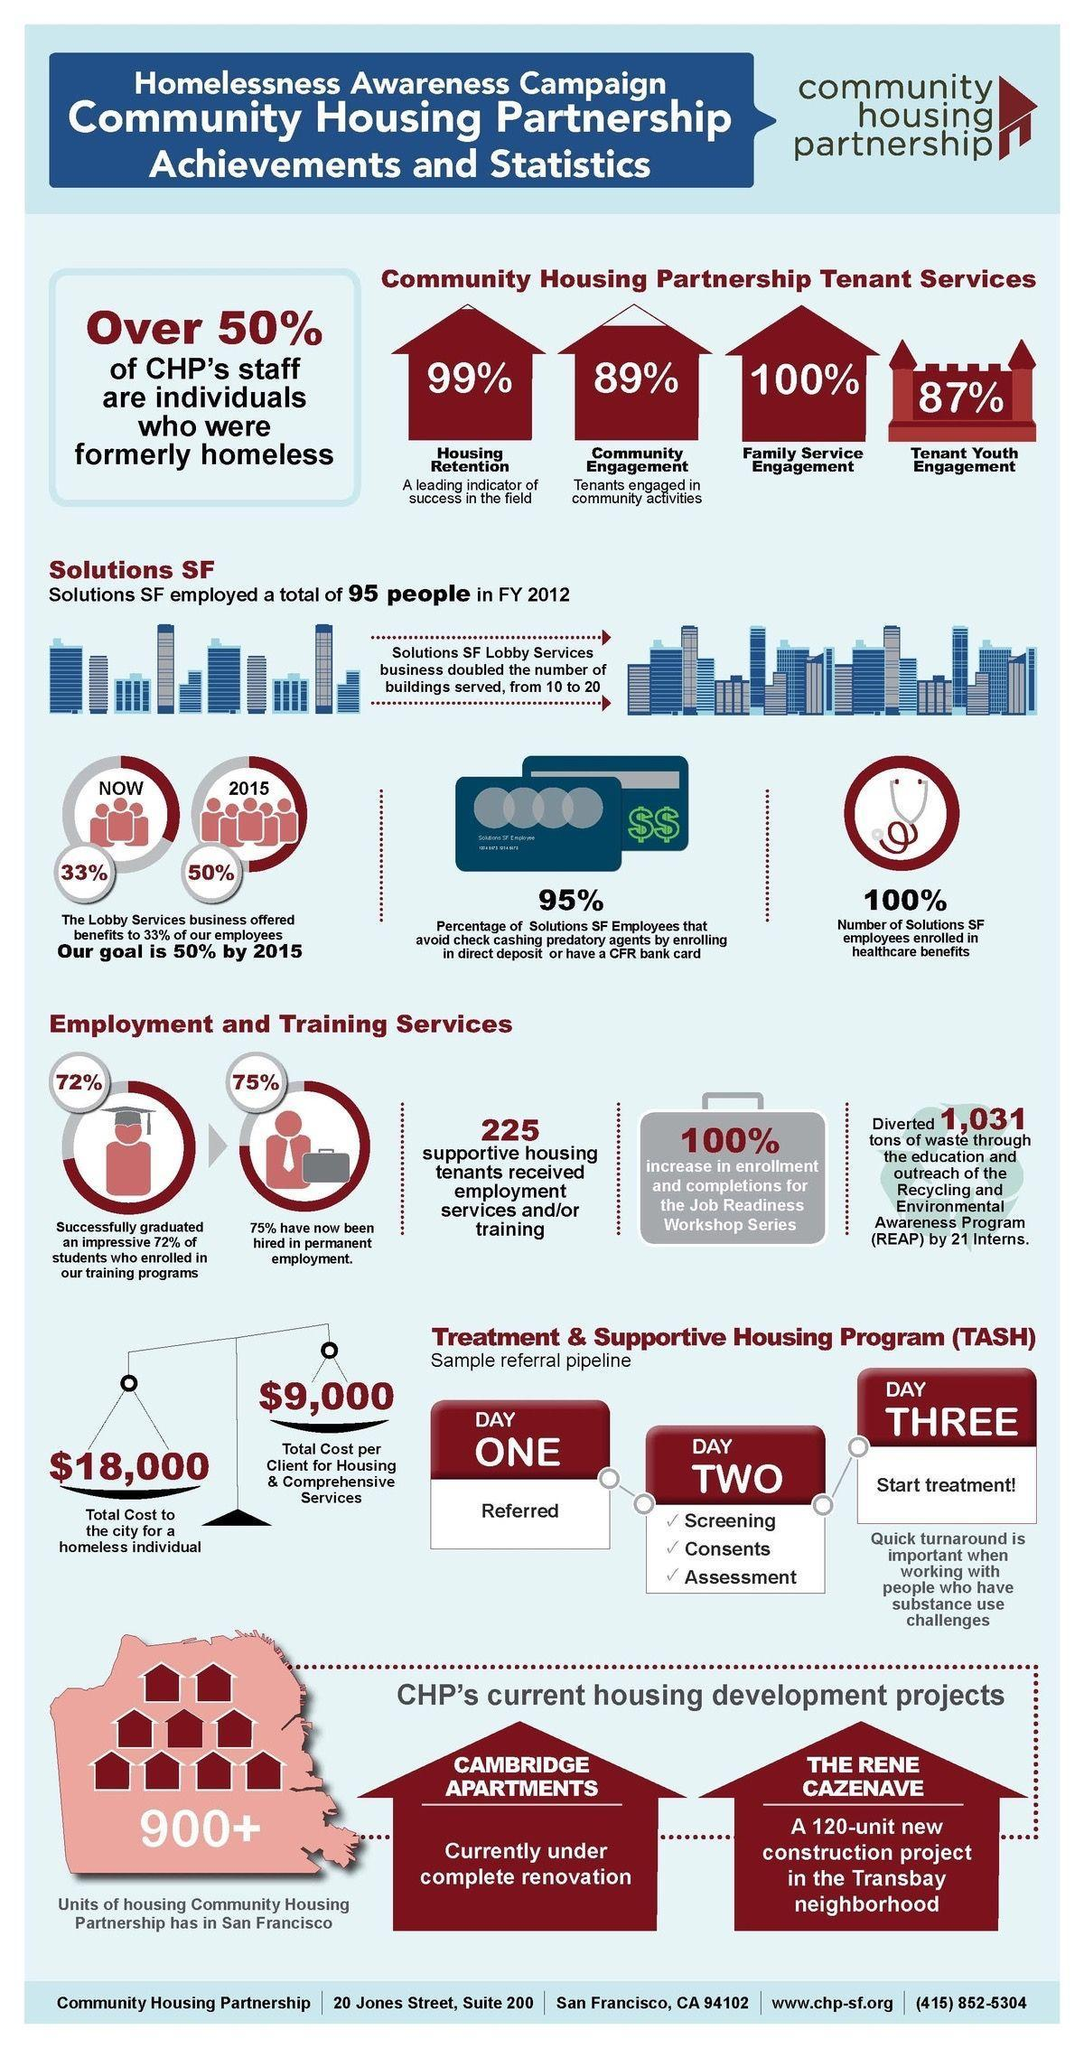What is the expected percentage of benefits offered by the lobby services business by 2015?
Answer the question with a short phrase. 50% What is the number of supportive housing tenants who has received employment and/or training? 225 What percentage of CHP's tenant services are for family service engagement? 100% What is the number of units of community housing partnership has in San Francisco? 900+ What percentage of CHP's tenant services are for community engagement? 89% What is the percentage of benefits offered by the lobby services business now? 33% What is the percentage increase in enrollment & completions for the job readiness workshop series? 100% 